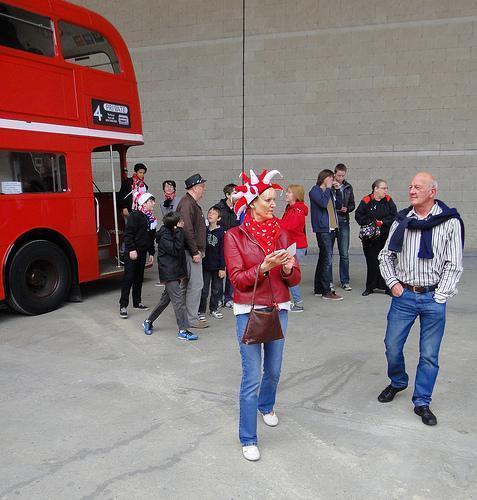How many buses are in the photo?
Give a very brief answer. 1. How many people are wearing jeans in the photo?
Give a very brief answer. 4. 